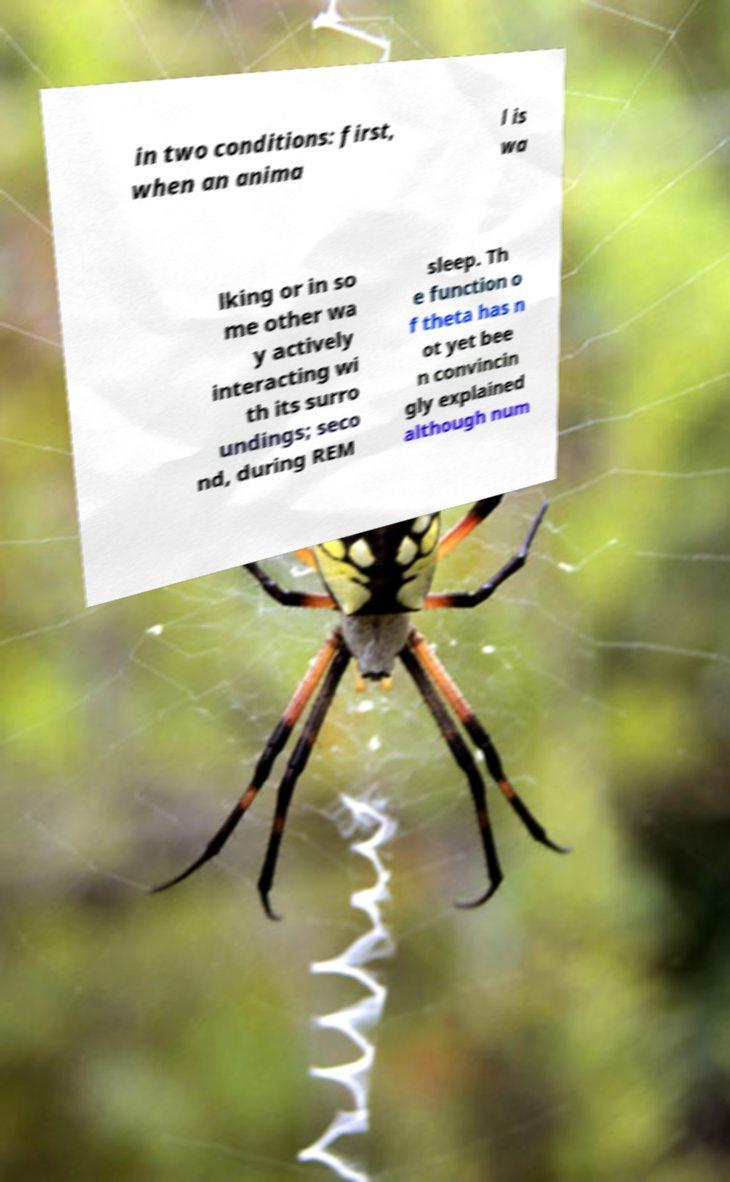For documentation purposes, I need the text within this image transcribed. Could you provide that? in two conditions: first, when an anima l is wa lking or in so me other wa y actively interacting wi th its surro undings; seco nd, during REM sleep. Th e function o f theta has n ot yet bee n convincin gly explained although num 